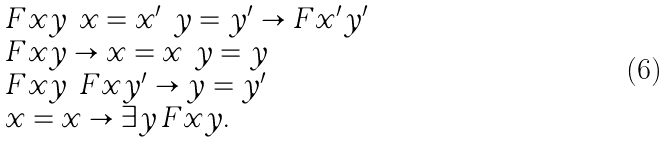Convert formula to latex. <formula><loc_0><loc_0><loc_500><loc_500>\begin{array} { l } F x y \land x = x ^ { \prime } \land y = y ^ { \prime } \rightarrow F x ^ { \prime } y ^ { \prime } \\ F x y \rightarrow x = x \land y = y \\ F x y \land F x y ^ { \prime } \rightarrow y = y ^ { \prime } \\ x = x \rightarrow \exists y \, F x y . \end{array}</formula> 